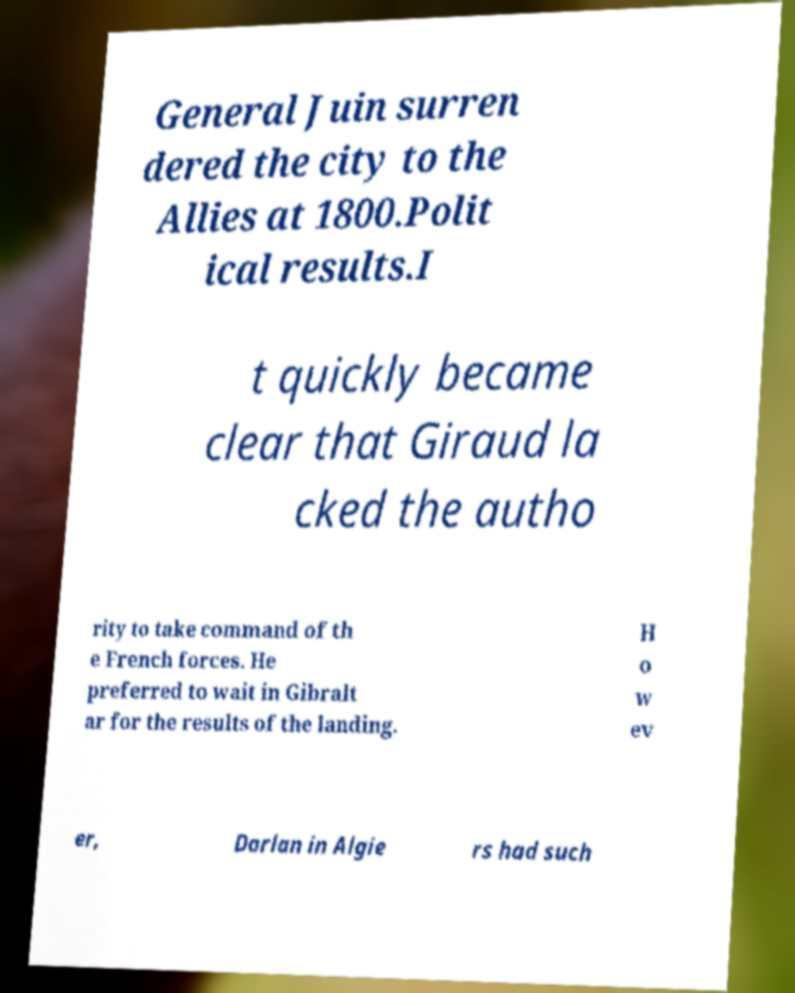Could you extract and type out the text from this image? General Juin surren dered the city to the Allies at 1800.Polit ical results.I t quickly became clear that Giraud la cked the autho rity to take command of th e French forces. He preferred to wait in Gibralt ar for the results of the landing. H o w ev er, Darlan in Algie rs had such 